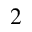Convert formula to latex. <formula><loc_0><loc_0><loc_500><loc_500>^ { 2 }</formula> 